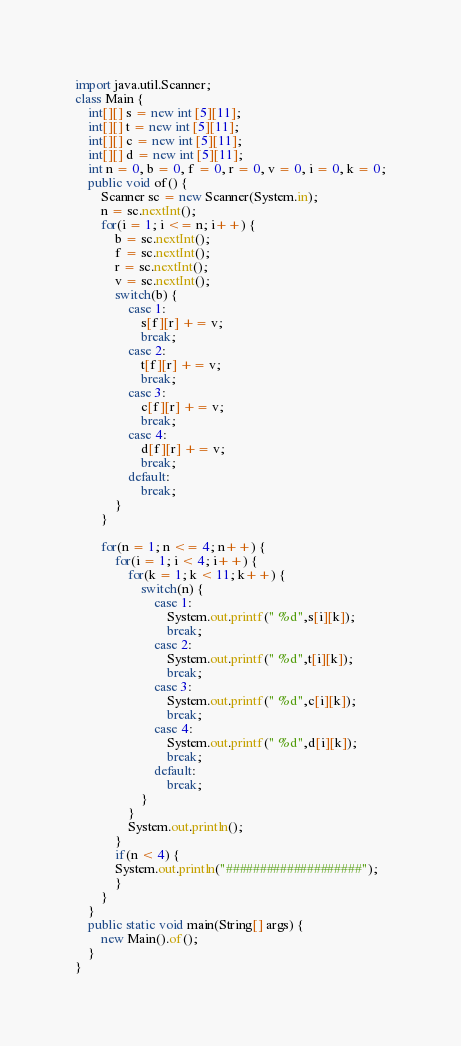Convert code to text. <code><loc_0><loc_0><loc_500><loc_500><_Java_>import java.util.Scanner;
class Main {
	int[][] s = new int [5][11];
	int[][] t = new int [5][11];
	int[][] c = new int [5][11];
	int[][] d = new int [5][11];
	int n = 0, b = 0, f = 0, r = 0, v = 0, i = 0, k = 0;
	public void of() {
		Scanner sc = new Scanner(System.in);
		n = sc.nextInt();
		for(i = 1; i <= n; i++) {
			b = sc.nextInt();
			f = sc.nextInt();
			r = sc.nextInt();
			v = sc.nextInt();
			switch(b) {
				case 1:
					s[f][r] += v;
					break;
				case 2:
					t[f][r] += v;
					break;
				case 3:
					c[f][r] += v;
					break;
				case 4:
					d[f][r] += v;
					break;
				default:
					break;
			}
		}
		
		for(n = 1; n <= 4; n++) {
			for(i = 1; i < 4; i++) {
				for(k = 1; k < 11; k++) {
					switch(n) {
						case 1:
							System.out.printf(" %d",s[i][k]);
							break;
						case 2:
							System.out.printf(" %d",t[i][k]);
							break;
						case 3:
							System.out.printf(" %d",c[i][k]);
							break;
						case 4:
							System.out.printf(" %d",d[i][k]);
							break;
						default:
							break;
					}
				}
				System.out.println();
			}
			if(n < 4) {
			System.out.println("####################");
			}
		}
	}
	public static void main(String[] args) {
		new Main().of();
	}
}</code> 